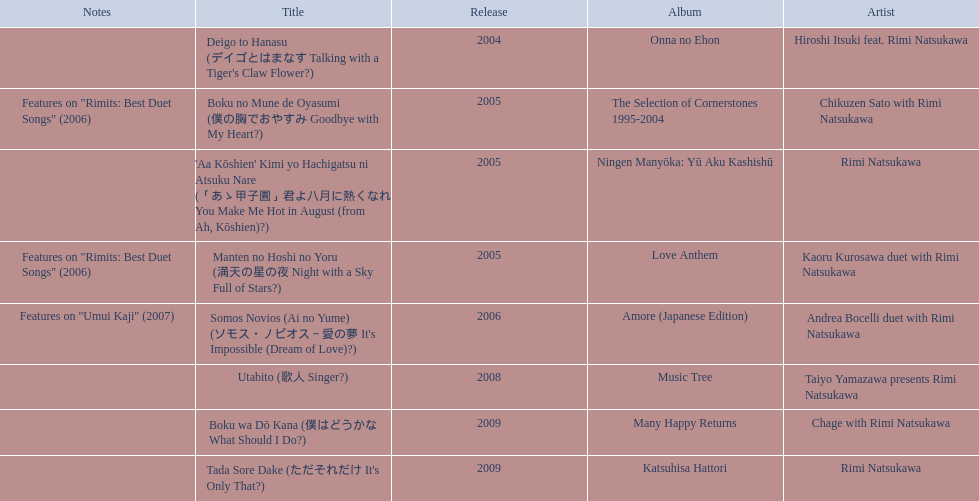Help me parse the entirety of this table. {'header': ['Notes', 'Title', 'Release', 'Album', 'Artist'], 'rows': [['', "Deigo to Hanasu (デイゴとはまなす Talking with a Tiger's Claw Flower?)", '2004', 'Onna no Ehon', 'Hiroshi Itsuki feat. Rimi Natsukawa'], ['Features on "Rimits: Best Duet Songs" (2006)', 'Boku no Mune de Oyasumi (僕の胸でおやすみ Goodbye with My Heart?)', '2005', 'The Selection of Cornerstones 1995-2004', 'Chikuzen Sato with Rimi Natsukawa'], ['', "'Aa Kōshien' Kimi yo Hachigatsu ni Atsuku Nare (「あゝ甲子園」君よ八月に熱くなれ You Make Me Hot in August (from Ah, Kōshien)?)", '2005', 'Ningen Manyōka: Yū Aku Kashishū', 'Rimi Natsukawa'], ['Features on "Rimits: Best Duet Songs" (2006)', 'Manten no Hoshi no Yoru (満天の星の夜 Night with a Sky Full of Stars?)', '2005', 'Love Anthem', 'Kaoru Kurosawa duet with Rimi Natsukawa'], ['Features on "Umui Kaji" (2007)', "Somos Novios (Ai no Yume) (ソモス・ノビオス～愛の夢 It's Impossible (Dream of Love)?)", '2006', 'Amore (Japanese Edition)', 'Andrea Bocelli duet with Rimi Natsukawa'], ['', 'Utabito (歌人 Singer?)', '2008', 'Music Tree', 'Taiyo Yamazawa presents Rimi Natsukawa'], ['', 'Boku wa Dō Kana (僕はどうかな What Should I Do?)', '2009', 'Many Happy Returns', 'Chage with Rimi Natsukawa'], ['', "Tada Sore Dake (ただそれだけ It's Only That?)", '2009', 'Katsuhisa Hattori', 'Rimi Natsukawa']]} Which title has the same notes as night with a sky full of stars? Boku no Mune de Oyasumi (僕の胸でおやすみ Goodbye with My Heart?). 